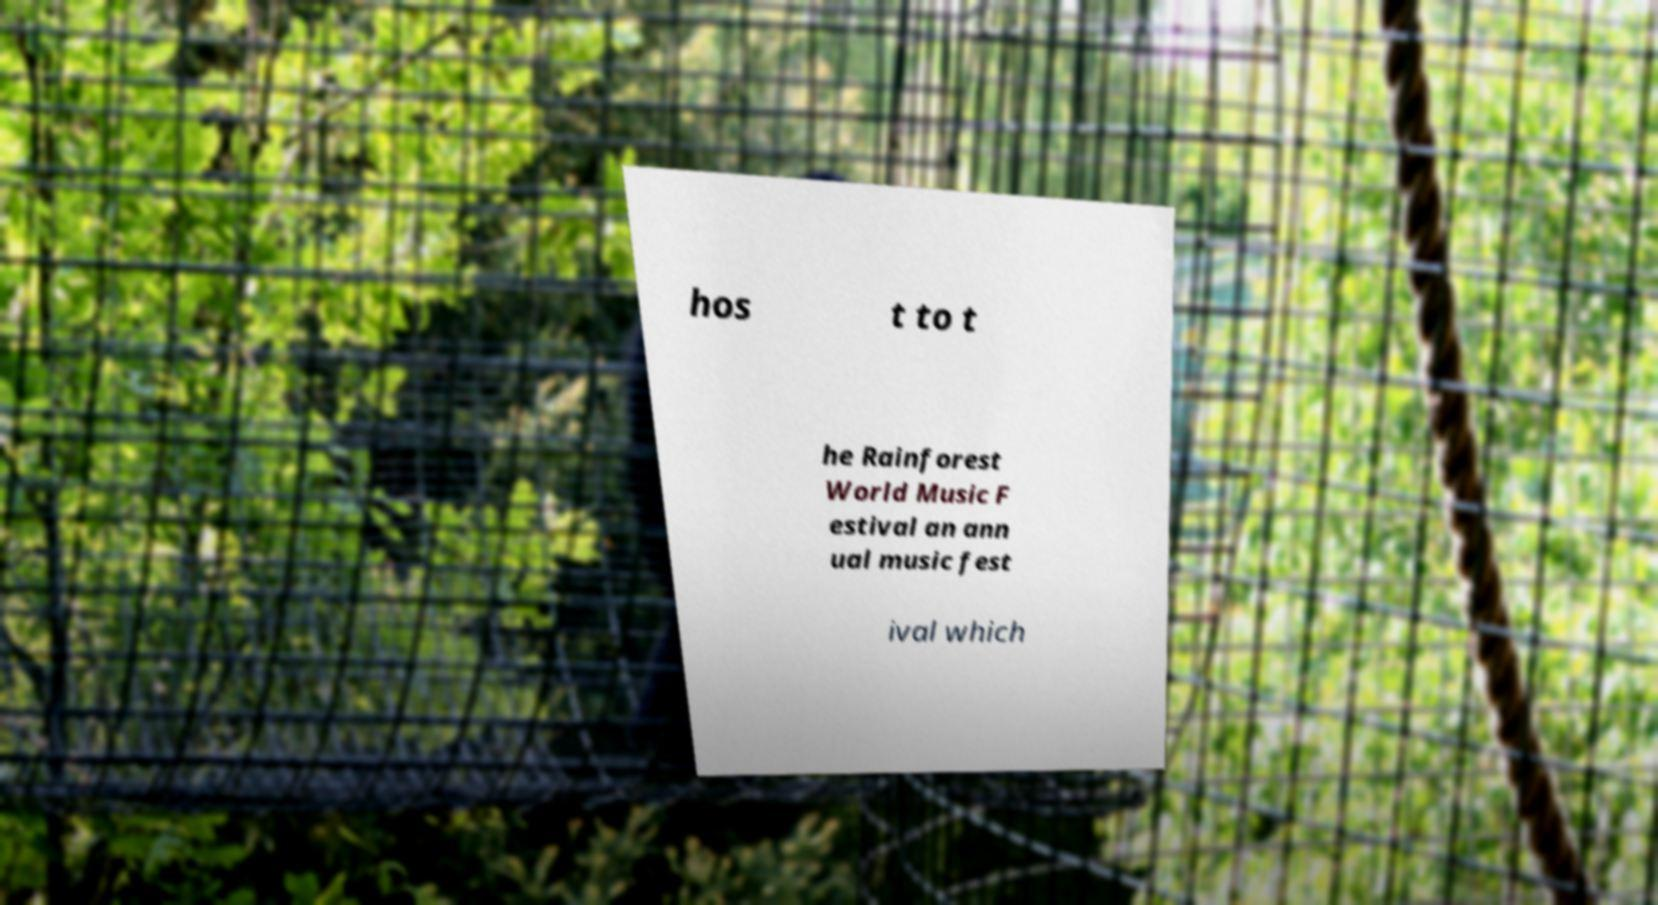Can you accurately transcribe the text from the provided image for me? hos t to t he Rainforest World Music F estival an ann ual music fest ival which 